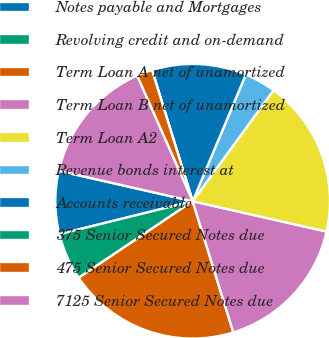Convert chart to OTSL. <chart><loc_0><loc_0><loc_500><loc_500><pie_chart><fcel>Notes payable and Mortgages<fcel>Revolving credit and on-demand<fcel>Term Loan A net of unamortized<fcel>Term Loan B net of unamortized<fcel>Term Loan A2<fcel>Revenue bonds interest at<fcel>Accounts receivable<fcel>375 Senior Secured Notes due<fcel>475 Senior Secured Notes due<fcel>7125 Senior Secured Notes due<nl><fcel>7.41%<fcel>5.56%<fcel>20.37%<fcel>16.67%<fcel>18.52%<fcel>3.7%<fcel>11.11%<fcel>0.0%<fcel>1.85%<fcel>14.81%<nl></chart> 